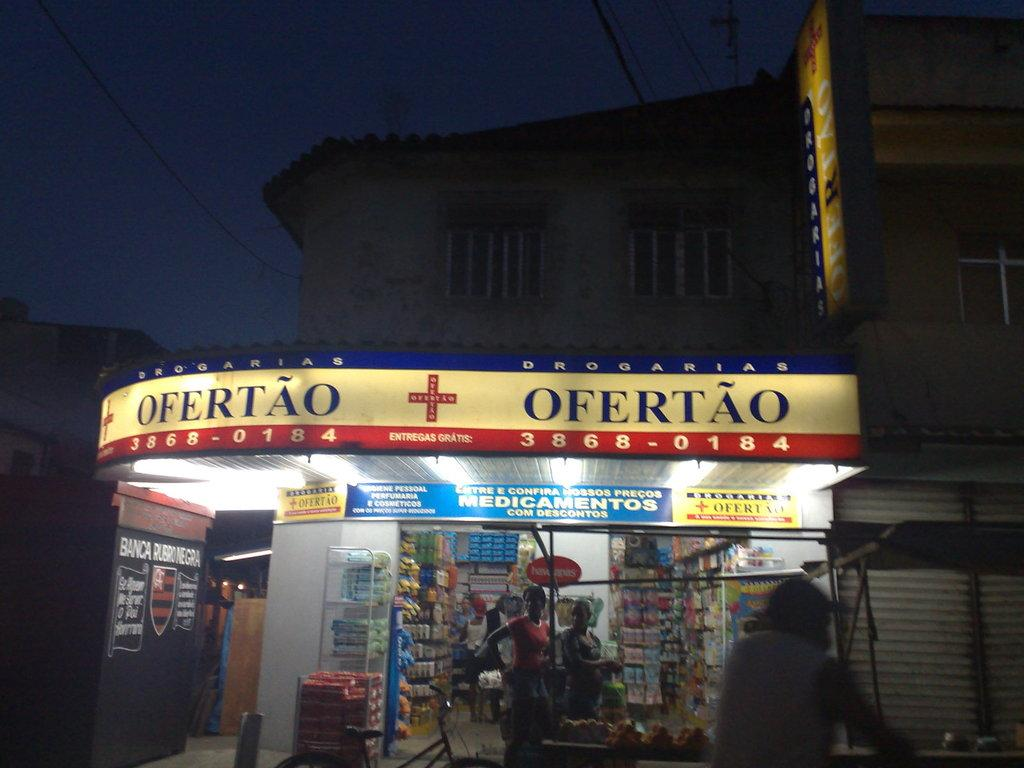Provide a one-sentence caption for the provided image. A CORNER STORE WITH THE SIGNBOARD "OFERTAO 3868-0184". 